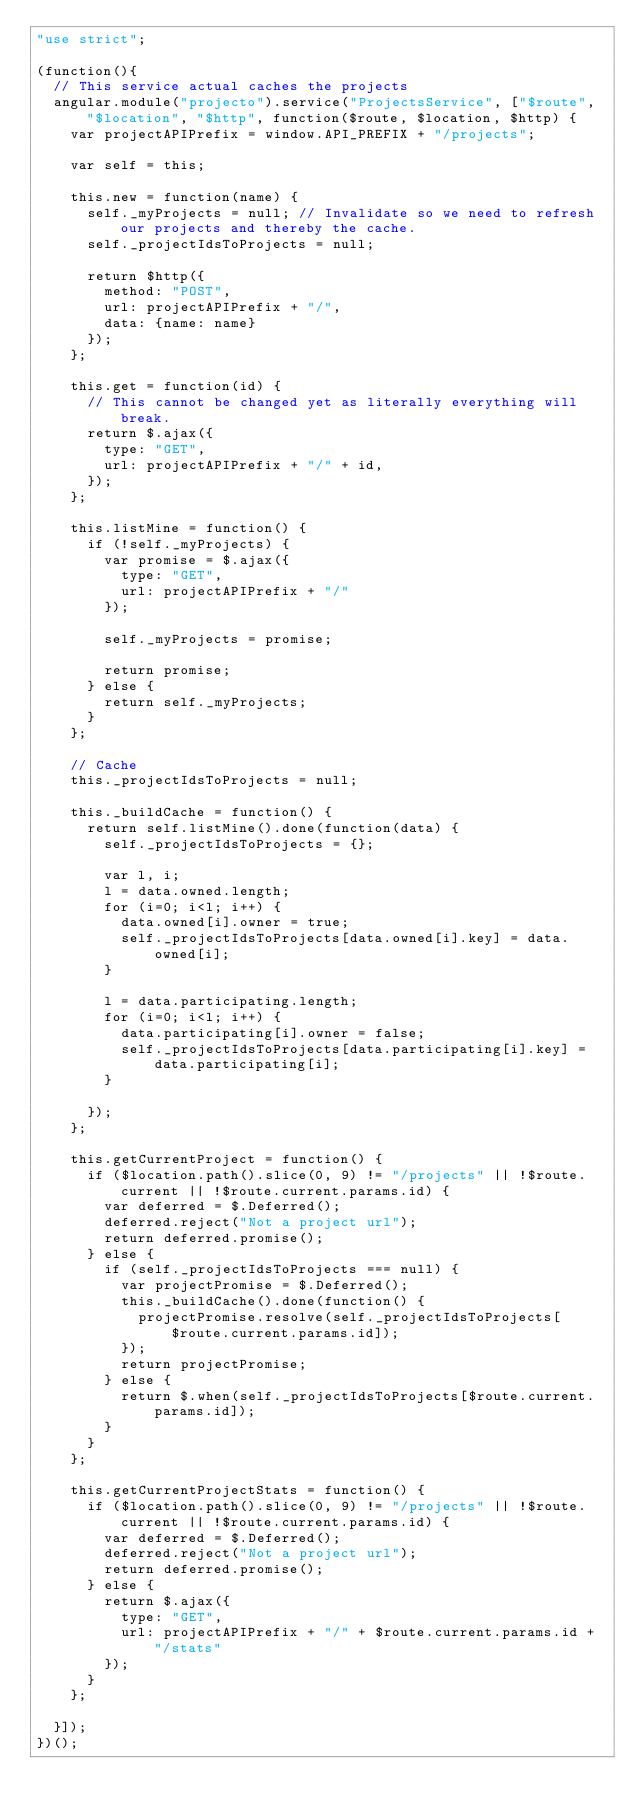Convert code to text. <code><loc_0><loc_0><loc_500><loc_500><_JavaScript_>"use strict";

(function(){
  // This service actual caches the projects
  angular.module("projecto").service("ProjectsService", ["$route", "$location", "$http", function($route, $location, $http) {
    var projectAPIPrefix = window.API_PREFIX + "/projects";

    var self = this;

    this.new = function(name) {
      self._myProjects = null; // Invalidate so we need to refresh our projects and thereby the cache.
      self._projectIdsToProjects = null;

      return $http({
        method: "POST",
        url: projectAPIPrefix + "/",
        data: {name: name}
      });
    };

    this.get = function(id) {
      // This cannot be changed yet as literally everything will break.
      return $.ajax({
        type: "GET",
        url: projectAPIPrefix + "/" + id,
      });
    };

    this.listMine = function() {
      if (!self._myProjects) {
        var promise = $.ajax({
          type: "GET",
          url: projectAPIPrefix + "/"
        });

        self._myProjects = promise;

        return promise;
      } else {
        return self._myProjects;
      }
    };

    // Cache
    this._projectIdsToProjects = null;

    this._buildCache = function() {
      return self.listMine().done(function(data) {
        self._projectIdsToProjects = {};

        var l, i;
        l = data.owned.length;
        for (i=0; i<l; i++) {
          data.owned[i].owner = true;
          self._projectIdsToProjects[data.owned[i].key] = data.owned[i];
        }

        l = data.participating.length;
        for (i=0; i<l; i++) {
          data.participating[i].owner = false;
          self._projectIdsToProjects[data.participating[i].key] = data.participating[i];
        }

      });
    };

    this.getCurrentProject = function() {
      if ($location.path().slice(0, 9) != "/projects" || !$route.current || !$route.current.params.id) {
        var deferred = $.Deferred();
        deferred.reject("Not a project url");
        return deferred.promise();
      } else {
        if (self._projectIdsToProjects === null) {
          var projectPromise = $.Deferred();
          this._buildCache().done(function() {
            projectPromise.resolve(self._projectIdsToProjects[$route.current.params.id]);
          });
          return projectPromise;
        } else {
          return $.when(self._projectIdsToProjects[$route.current.params.id]);
        }
      }
    };

    this.getCurrentProjectStats = function() {
      if ($location.path().slice(0, 9) != "/projects" || !$route.current || !$route.current.params.id) {
        var deferred = $.Deferred();
        deferred.reject("Not a project url");
        return deferred.promise();
      } else {
        return $.ajax({
          type: "GET",
          url: projectAPIPrefix + "/" + $route.current.params.id + "/stats"
        });
      }
    };

  }]);
})();</code> 